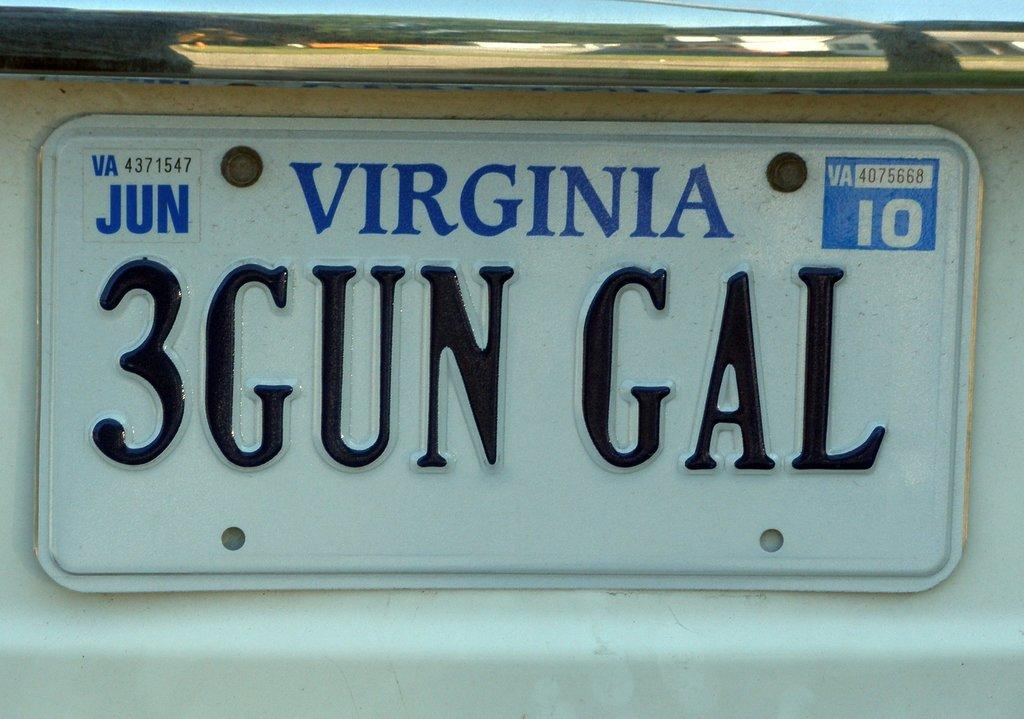<image>
Describe the image concisely. White license plate from Virginia with the title 3GUNGAL. 